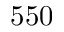<formula> <loc_0><loc_0><loc_500><loc_500>5 5 0</formula> 